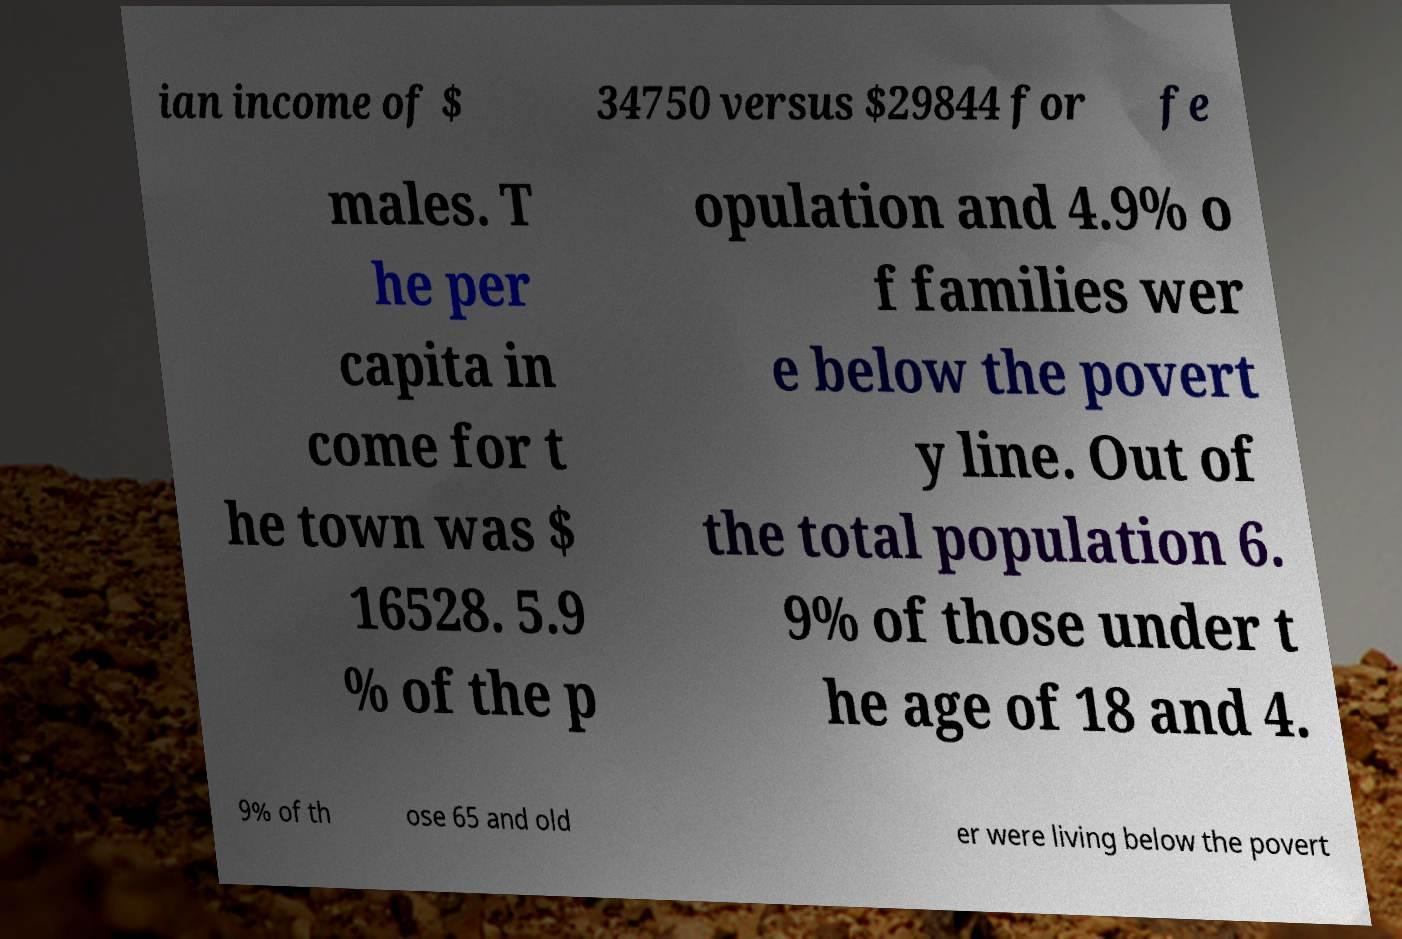Can you accurately transcribe the text from the provided image for me? ian income of $ 34750 versus $29844 for fe males. T he per capita in come for t he town was $ 16528. 5.9 % of the p opulation and 4.9% o f families wer e below the povert y line. Out of the total population 6. 9% of those under t he age of 18 and 4. 9% of th ose 65 and old er were living below the povert 